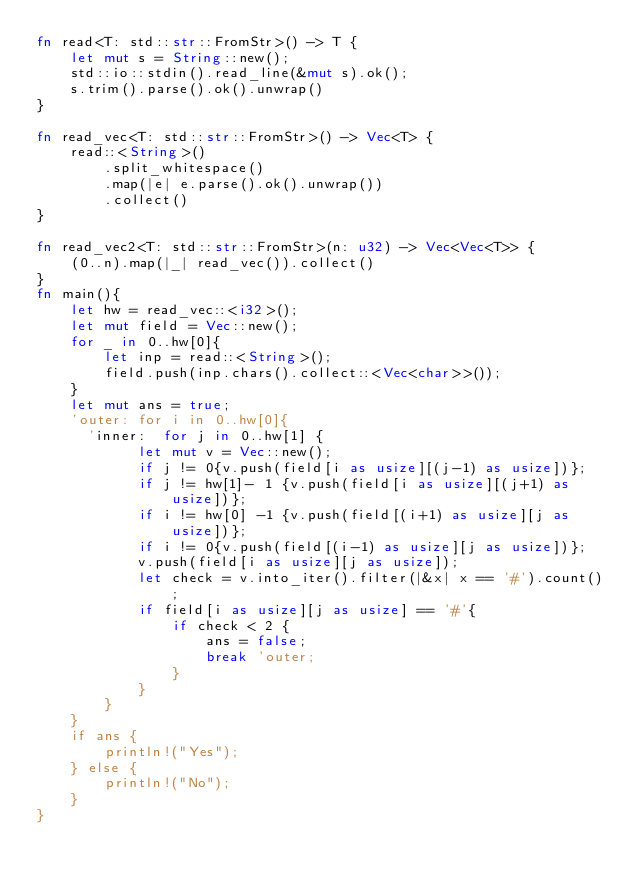Convert code to text. <code><loc_0><loc_0><loc_500><loc_500><_Rust_>fn read<T: std::str::FromStr>() -> T {
    let mut s = String::new();
    std::io::stdin().read_line(&mut s).ok();
    s.trim().parse().ok().unwrap()
}

fn read_vec<T: std::str::FromStr>() -> Vec<T> {
    read::<String>()
        .split_whitespace()
        .map(|e| e.parse().ok().unwrap())
        .collect()
}

fn read_vec2<T: std::str::FromStr>(n: u32) -> Vec<Vec<T>> {
    (0..n).map(|_| read_vec()).collect()
}
fn main(){
    let hw = read_vec::<i32>();
    let mut field = Vec::new();
    for _ in 0..hw[0]{
        let inp = read::<String>();
        field.push(inp.chars().collect::<Vec<char>>());
    }
    let mut ans = true;
    'outer: for i in 0..hw[0]{
      'inner:  for j in 0..hw[1] {
            let mut v = Vec::new();
            if j != 0{v.push(field[i as usize][(j-1) as usize])};
            if j != hw[1]- 1 {v.push(field[i as usize][(j+1) as usize])};
            if i != hw[0] -1 {v.push(field[(i+1) as usize][j as usize])};
            if i != 0{v.push(field[(i-1) as usize][j as usize])};
            v.push(field[i as usize][j as usize]);
            let check = v.into_iter().filter(|&x| x == '#').count();
            if field[i as usize][j as usize] == '#'{
                if check < 2 {
                    ans = false;
                    break 'outer;
                }
            }
        }
    }
    if ans {
        println!("Yes");
    } else {
        println!("No");
    }
}

</code> 